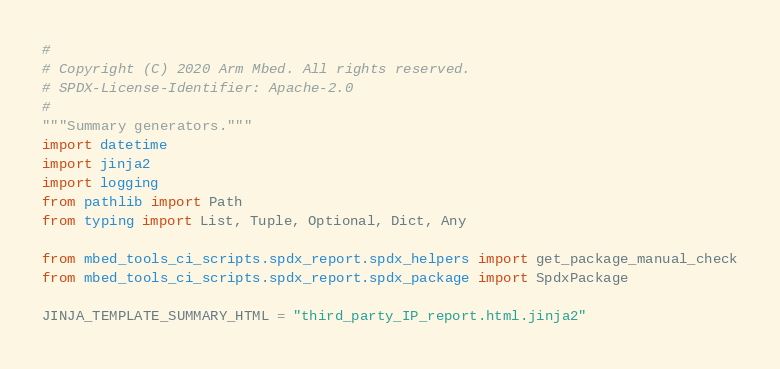Convert code to text. <code><loc_0><loc_0><loc_500><loc_500><_Python_>#
# Copyright (C) 2020 Arm Mbed. All rights reserved.
# SPDX-License-Identifier: Apache-2.0
#
"""Summary generators."""
import datetime
import jinja2
import logging
from pathlib import Path
from typing import List, Tuple, Optional, Dict, Any

from mbed_tools_ci_scripts.spdx_report.spdx_helpers import get_package_manual_check
from mbed_tools_ci_scripts.spdx_report.spdx_package import SpdxPackage

JINJA_TEMPLATE_SUMMARY_HTML = "third_party_IP_report.html.jinja2"</code> 